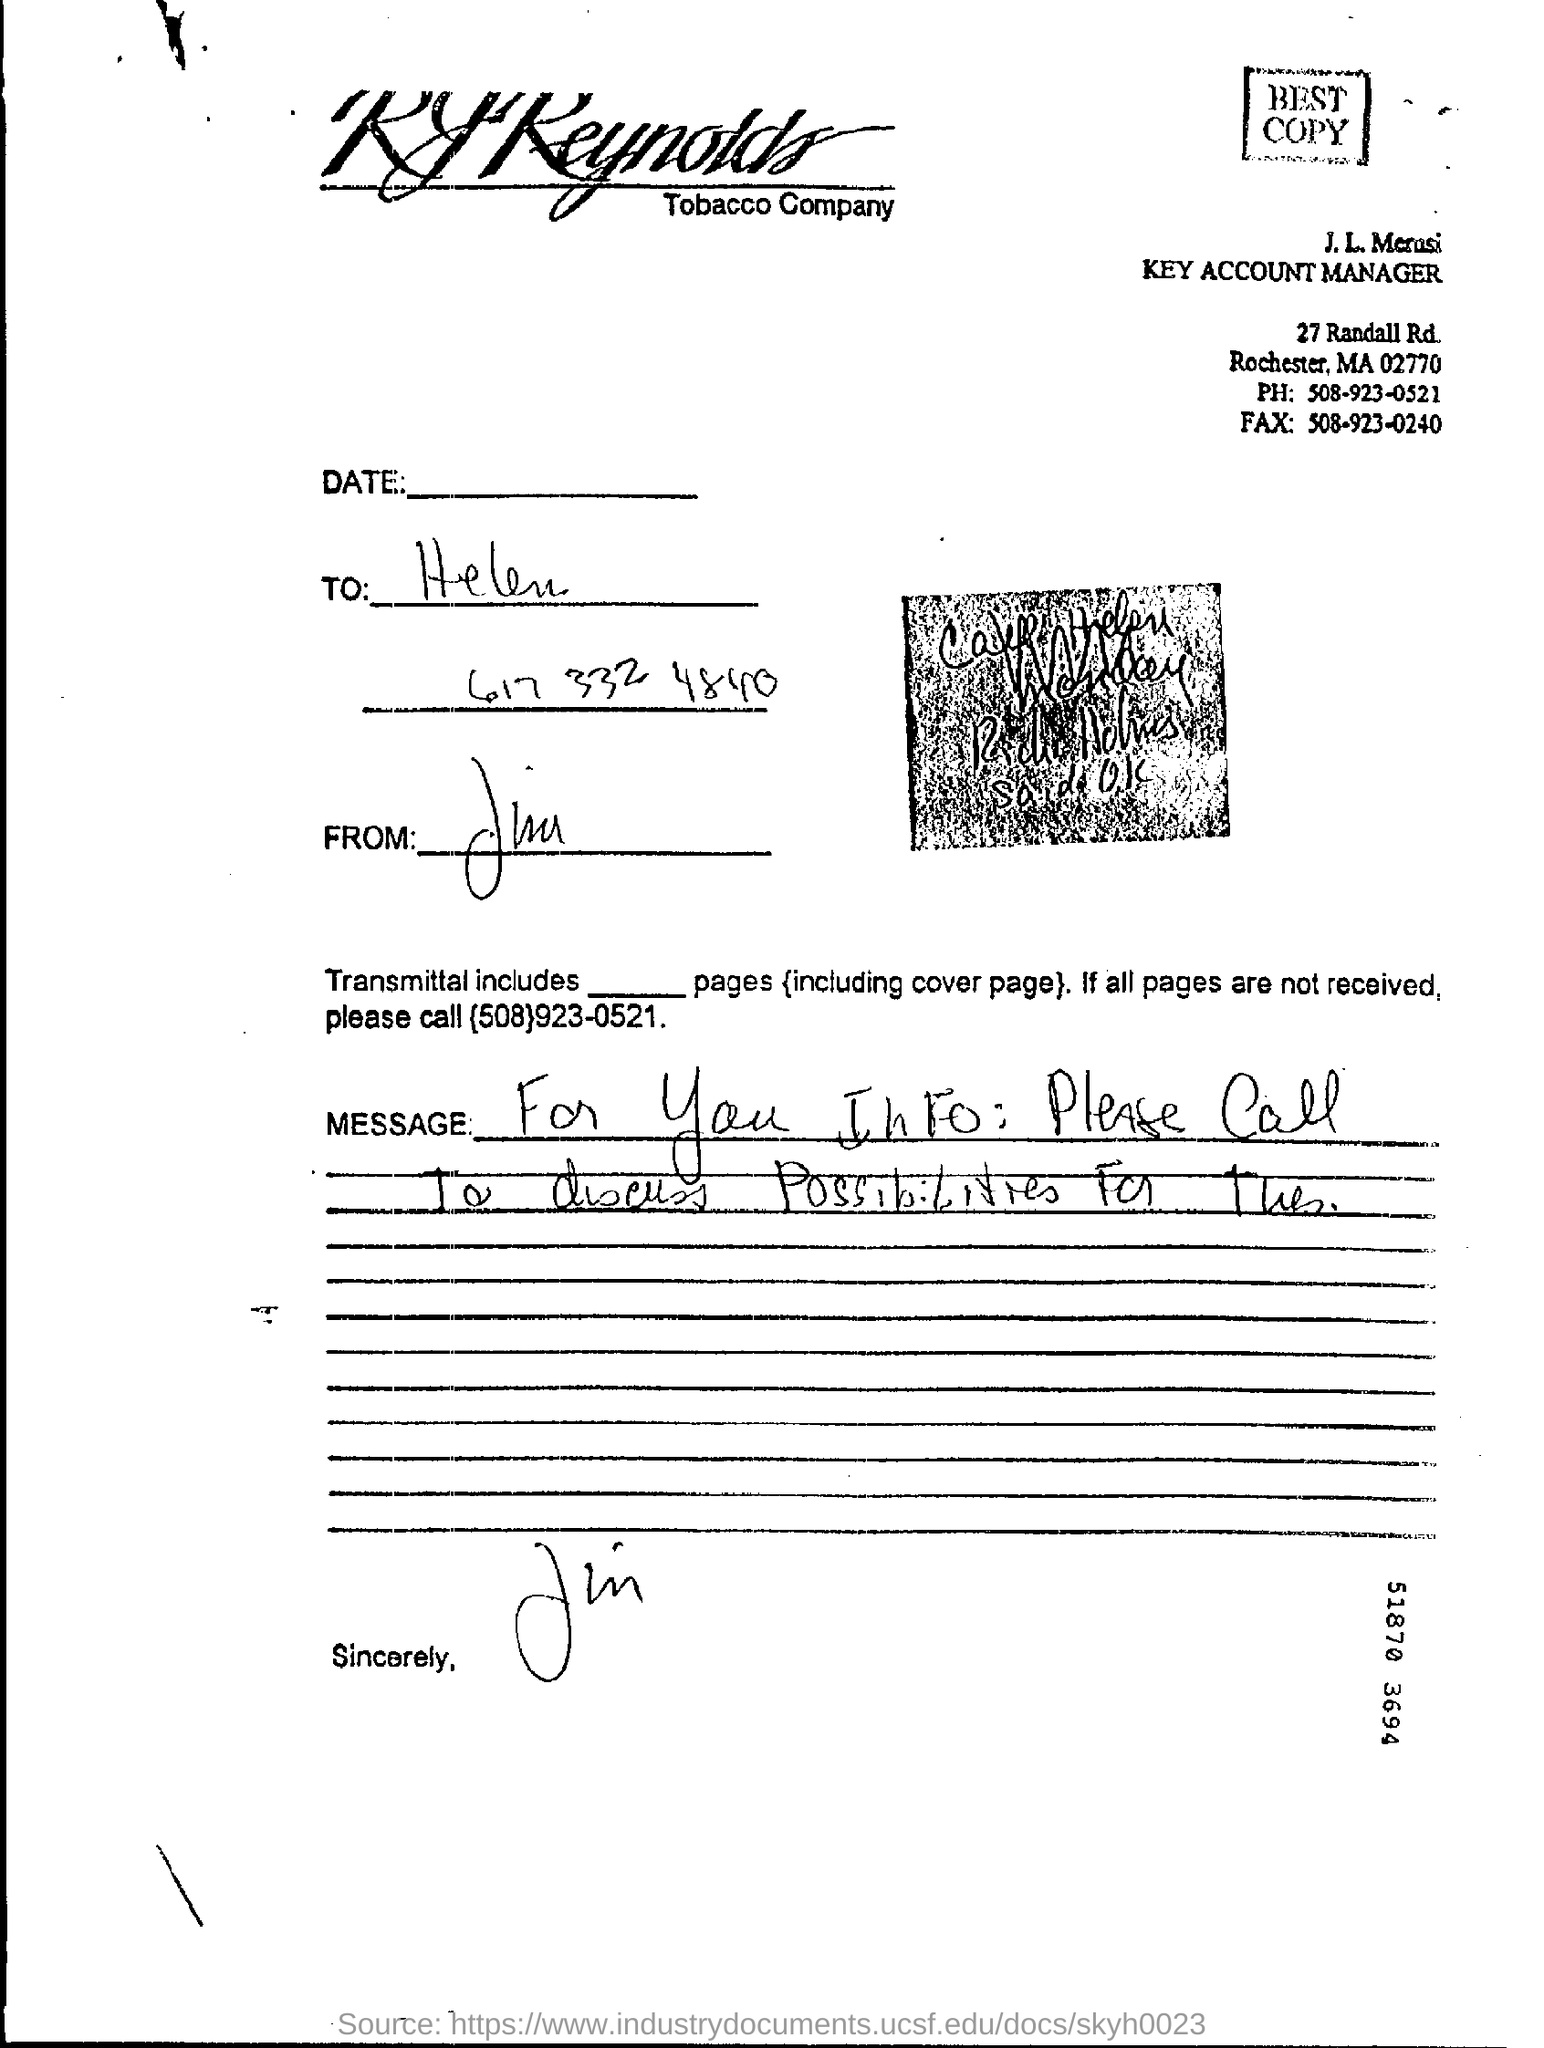What is the phone no mentioned in the letter ?
Make the answer very short. 508-923-0521. What is the fax number mentioned in the letter ?
Provide a succinct answer. 508-923-0240. 